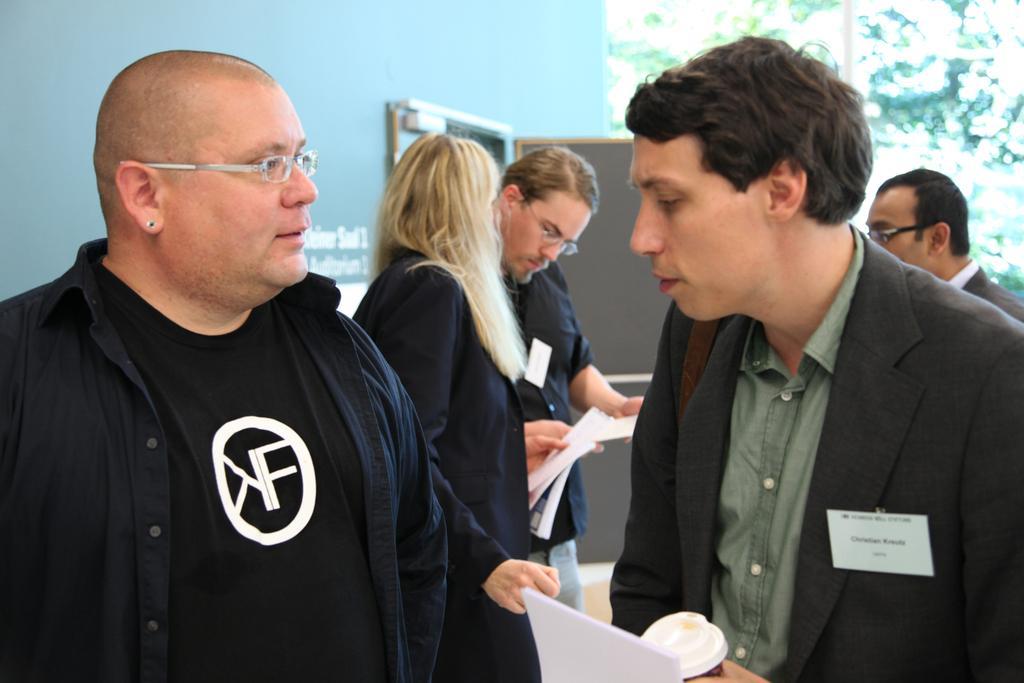In one or two sentences, can you explain what this image depicts? In this picture there is a man who is wearing shirt, blazer and holding a bottle and paper. In front of him there is another man who is wearing spectacle, shirt and t-shirt. In the back there are three person who are standing on the floor. Beside them there is a door. In the top right I can see some trees. 